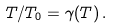Convert formula to latex. <formula><loc_0><loc_0><loc_500><loc_500>T / T _ { 0 } = \gamma ( T ) \, .</formula> 